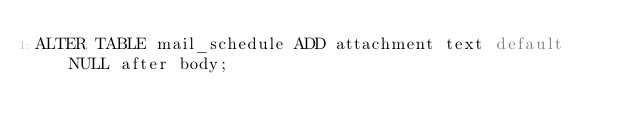Convert code to text. <code><loc_0><loc_0><loc_500><loc_500><_SQL_>ALTER TABLE mail_schedule ADD attachment text default NULL after body;</code> 